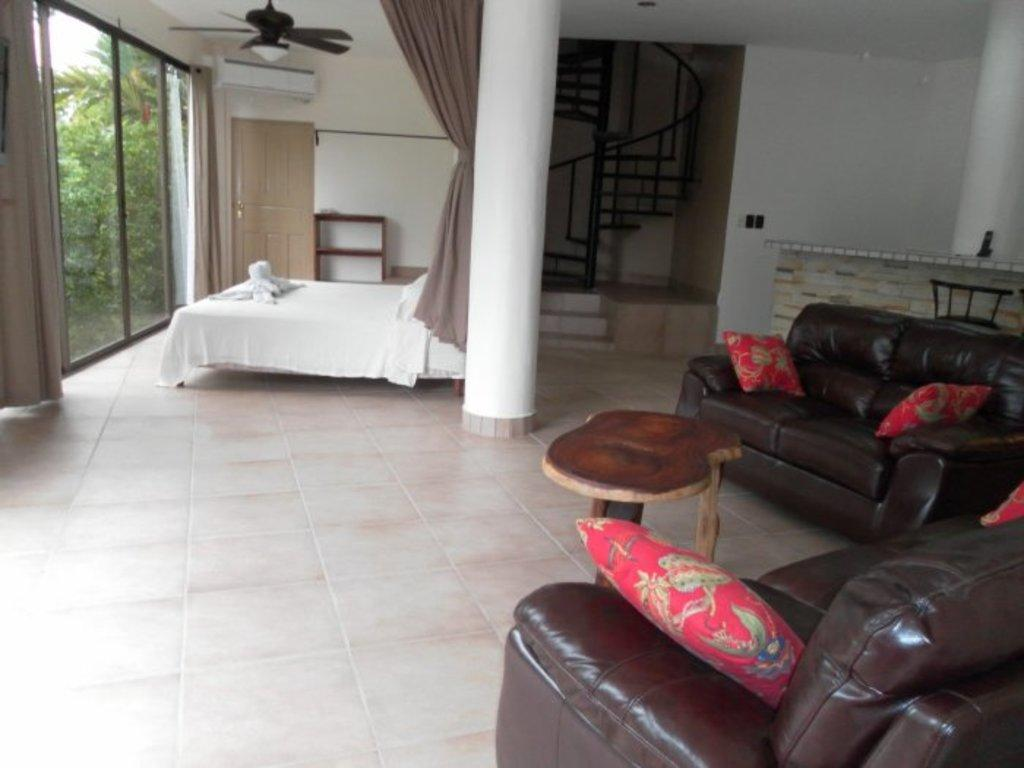What type of space is depicted in the image? The image shows an inner view of a house. What type of furniture is present in the image? There is a sofa, a table, and a bed in the image. Are there any architectural features visible in the image? Yes, there are stairs in the image. How many boys are playing with the animal in the image? There are no boys or animals present in the image. What is the primary use of the bed in the image? The primary use of the bed in the image is for sleeping or resting, but the image does not show anyone using it. 